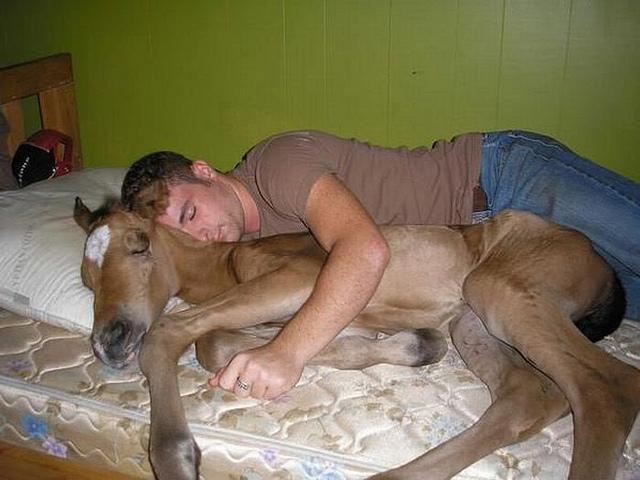How many chairs are there?
Give a very brief answer. 0. 